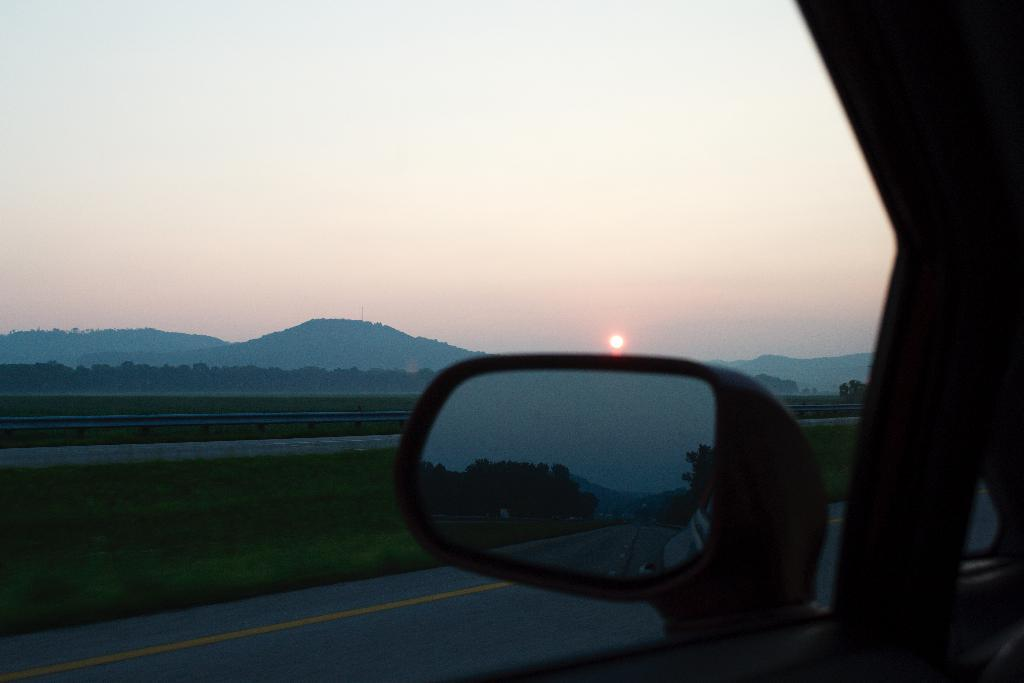What type of natural formation can be seen in the image? There are mountains in the image. What type of vegetation is present in the image? There are trees in the image. What type of structure can be seen in the image? There is fencing in the image. What is visible in the sky in the image? The sky is visible in the image, and the sun is also visible. What type of transportation is present in the image? There is a vehicle in the image. What object in the image might be used for reflection? There is a mirror in the image. What type of lock can be seen on the vehicle in the image? There is no lock visible on the vehicle in the image. What type of body is present in the image? There is no body present in the image; it features mountains, trees, fencing, the sky, the sun, a vehicle, and a mirror. 